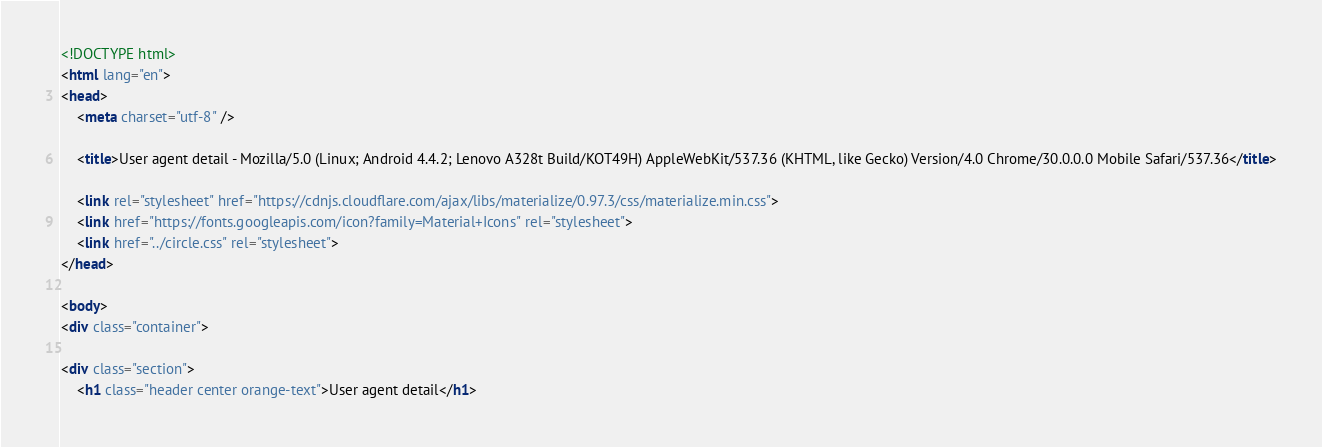<code> <loc_0><loc_0><loc_500><loc_500><_HTML_>
<!DOCTYPE html>
<html lang="en">
<head>
    <meta charset="utf-8" />
            
    <title>User agent detail - Mozilla/5.0 (Linux; Android 4.4.2; Lenovo A328t Build/KOT49H) AppleWebKit/537.36 (KHTML, like Gecko) Version/4.0 Chrome/30.0.0.0 Mobile Safari/537.36</title>
        
    <link rel="stylesheet" href="https://cdnjs.cloudflare.com/ajax/libs/materialize/0.97.3/css/materialize.min.css">
    <link href="https://fonts.googleapis.com/icon?family=Material+Icons" rel="stylesheet">
    <link href="../circle.css" rel="stylesheet">
</head>
        
<body>
<div class="container">
    
<div class="section">
	<h1 class="header center orange-text">User agent detail</h1></code> 